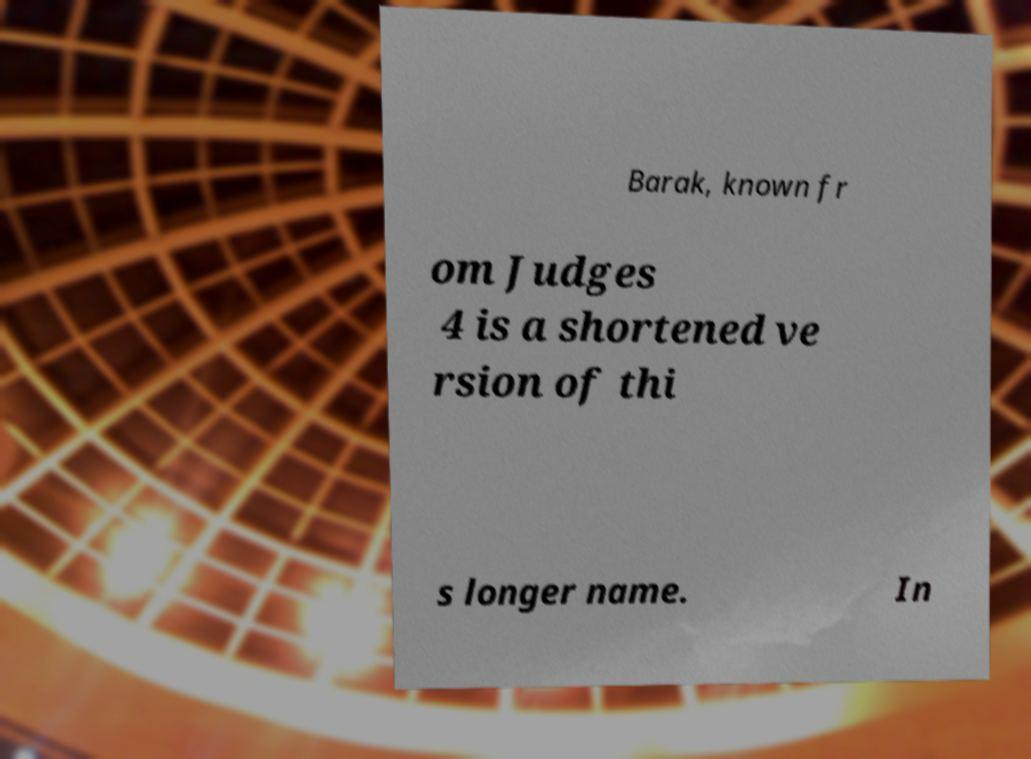Please identify and transcribe the text found in this image. Barak, known fr om Judges 4 is a shortened ve rsion of thi s longer name. In 